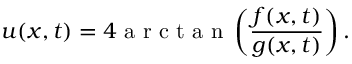<formula> <loc_0><loc_0><loc_500><loc_500>u ( x , t ) = 4 a r c t a n \left ( \frac { f ( x , t ) } { g ( x , t ) } \right ) .</formula> 